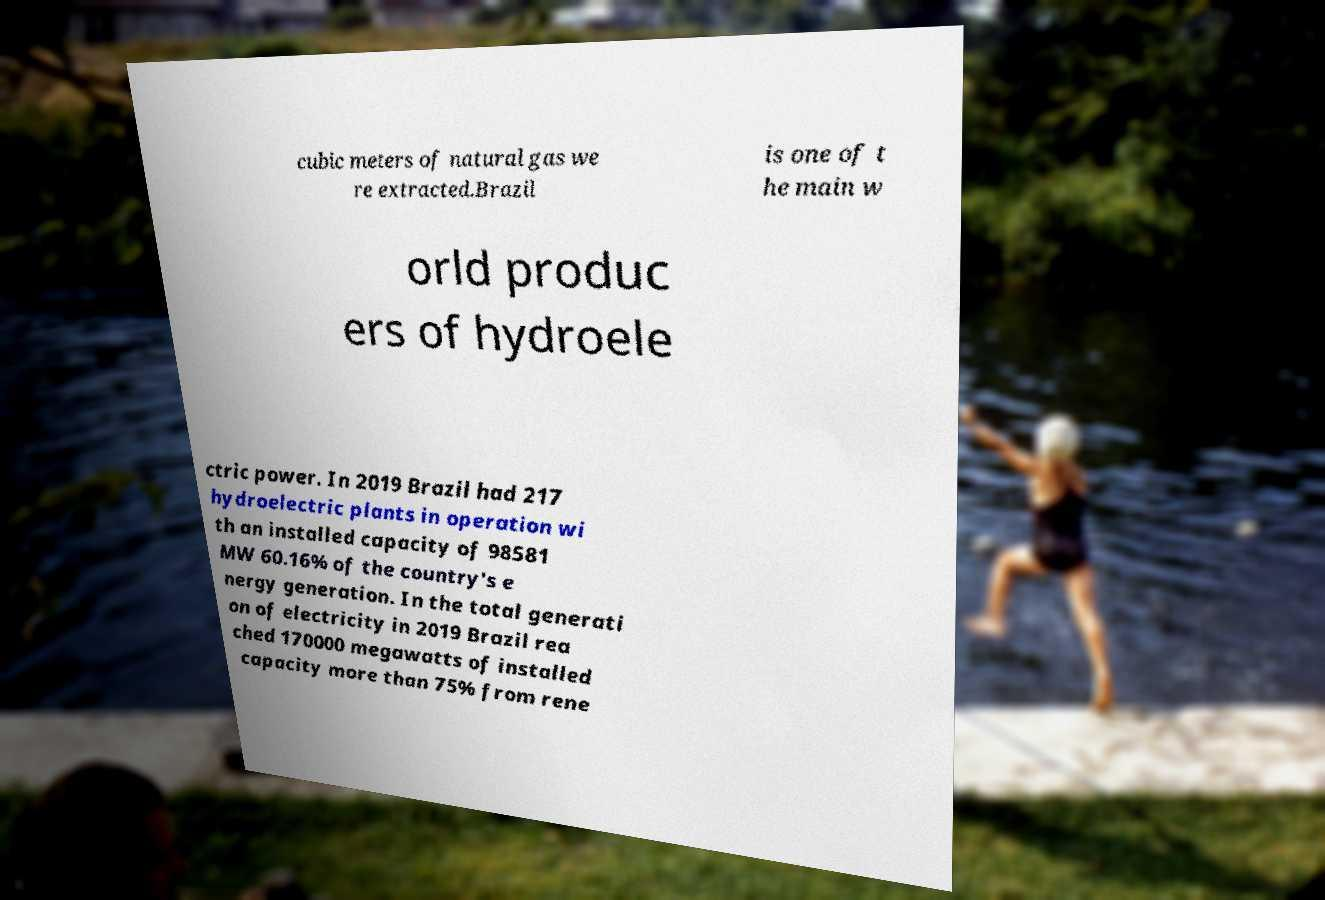There's text embedded in this image that I need extracted. Can you transcribe it verbatim? cubic meters of natural gas we re extracted.Brazil is one of t he main w orld produc ers of hydroele ctric power. In 2019 Brazil had 217 hydroelectric plants in operation wi th an installed capacity of 98581 MW 60.16% of the country's e nergy generation. In the total generati on of electricity in 2019 Brazil rea ched 170000 megawatts of installed capacity more than 75% from rene 